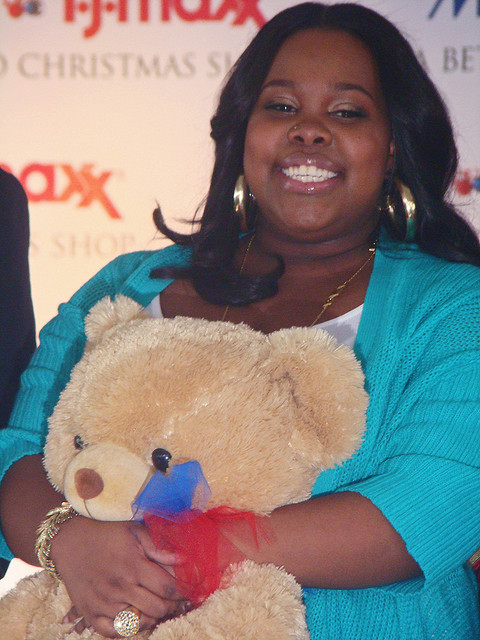Read and extract the text from this image. CHRISTMAS 